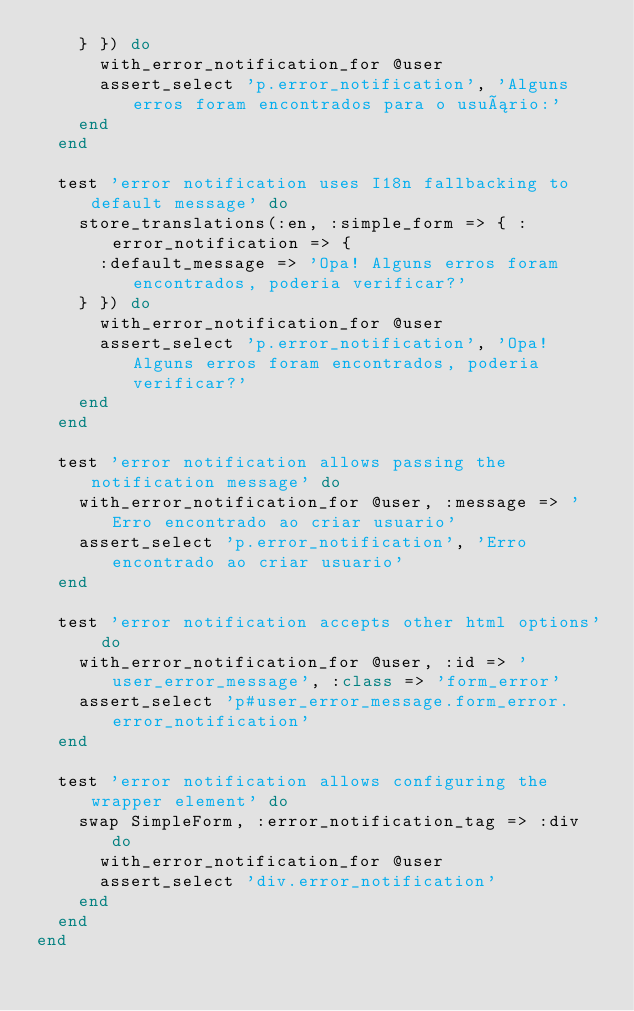Convert code to text. <code><loc_0><loc_0><loc_500><loc_500><_Ruby_>    } }) do
      with_error_notification_for @user
      assert_select 'p.error_notification', 'Alguns erros foram encontrados para o usuário:'
    end
  end

  test 'error notification uses I18n fallbacking to default message' do
    store_translations(:en, :simple_form => { :error_notification => {
      :default_message => 'Opa! Alguns erros foram encontrados, poderia verificar?'
    } }) do
      with_error_notification_for @user
      assert_select 'p.error_notification', 'Opa! Alguns erros foram encontrados, poderia verificar?'
    end
  end

  test 'error notification allows passing the notification message' do
    with_error_notification_for @user, :message => 'Erro encontrado ao criar usuario'
    assert_select 'p.error_notification', 'Erro encontrado ao criar usuario'
  end

  test 'error notification accepts other html options' do
    with_error_notification_for @user, :id => 'user_error_message', :class => 'form_error'
    assert_select 'p#user_error_message.form_error.error_notification'
  end

  test 'error notification allows configuring the wrapper element' do
    swap SimpleForm, :error_notification_tag => :div do
      with_error_notification_for @user
      assert_select 'div.error_notification'
    end
  end
end
</code> 